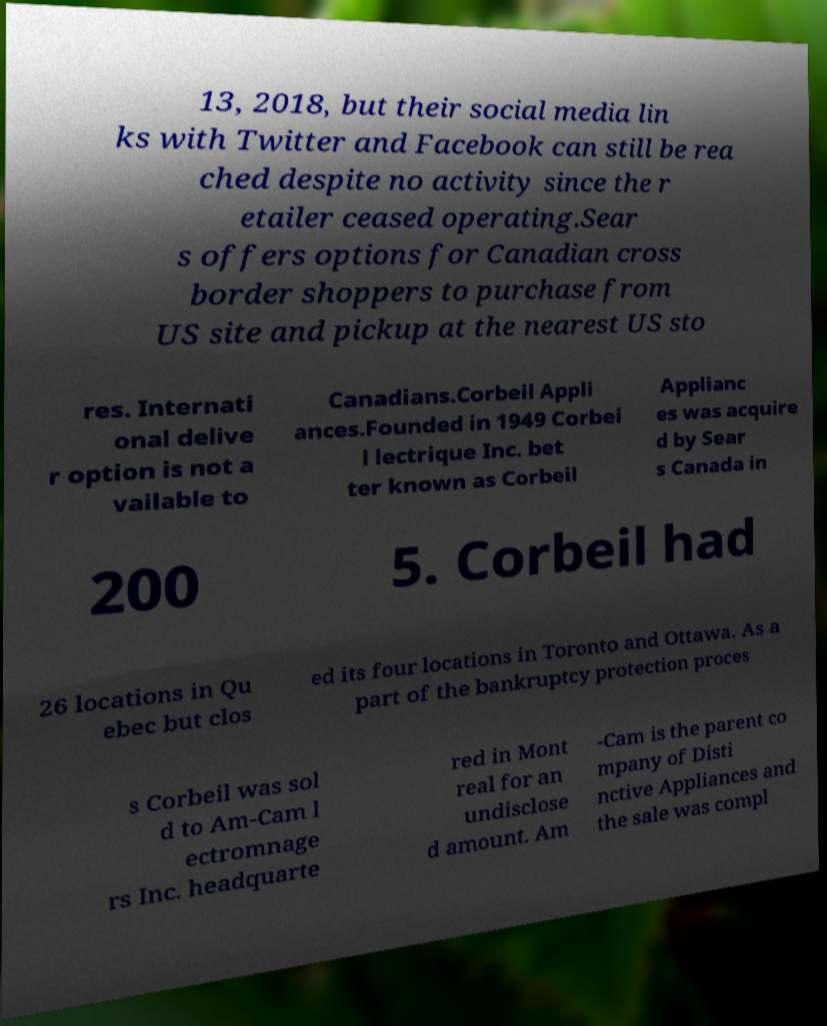Can you accurately transcribe the text from the provided image for me? 13, 2018, but their social media lin ks with Twitter and Facebook can still be rea ched despite no activity since the r etailer ceased operating.Sear s offers options for Canadian cross border shoppers to purchase from US site and pickup at the nearest US sto res. Internati onal delive r option is not a vailable to Canadians.Corbeil Appli ances.Founded in 1949 Corbei l lectrique Inc. bet ter known as Corbeil Applianc es was acquire d by Sear s Canada in 200 5. Corbeil had 26 locations in Qu ebec but clos ed its four locations in Toronto and Ottawa. As a part of the bankruptcy protection proces s Corbeil was sol d to Am-Cam l ectromnage rs Inc. headquarte red in Mont real for an undisclose d amount. Am -Cam is the parent co mpany of Disti nctive Appliances and the sale was compl 